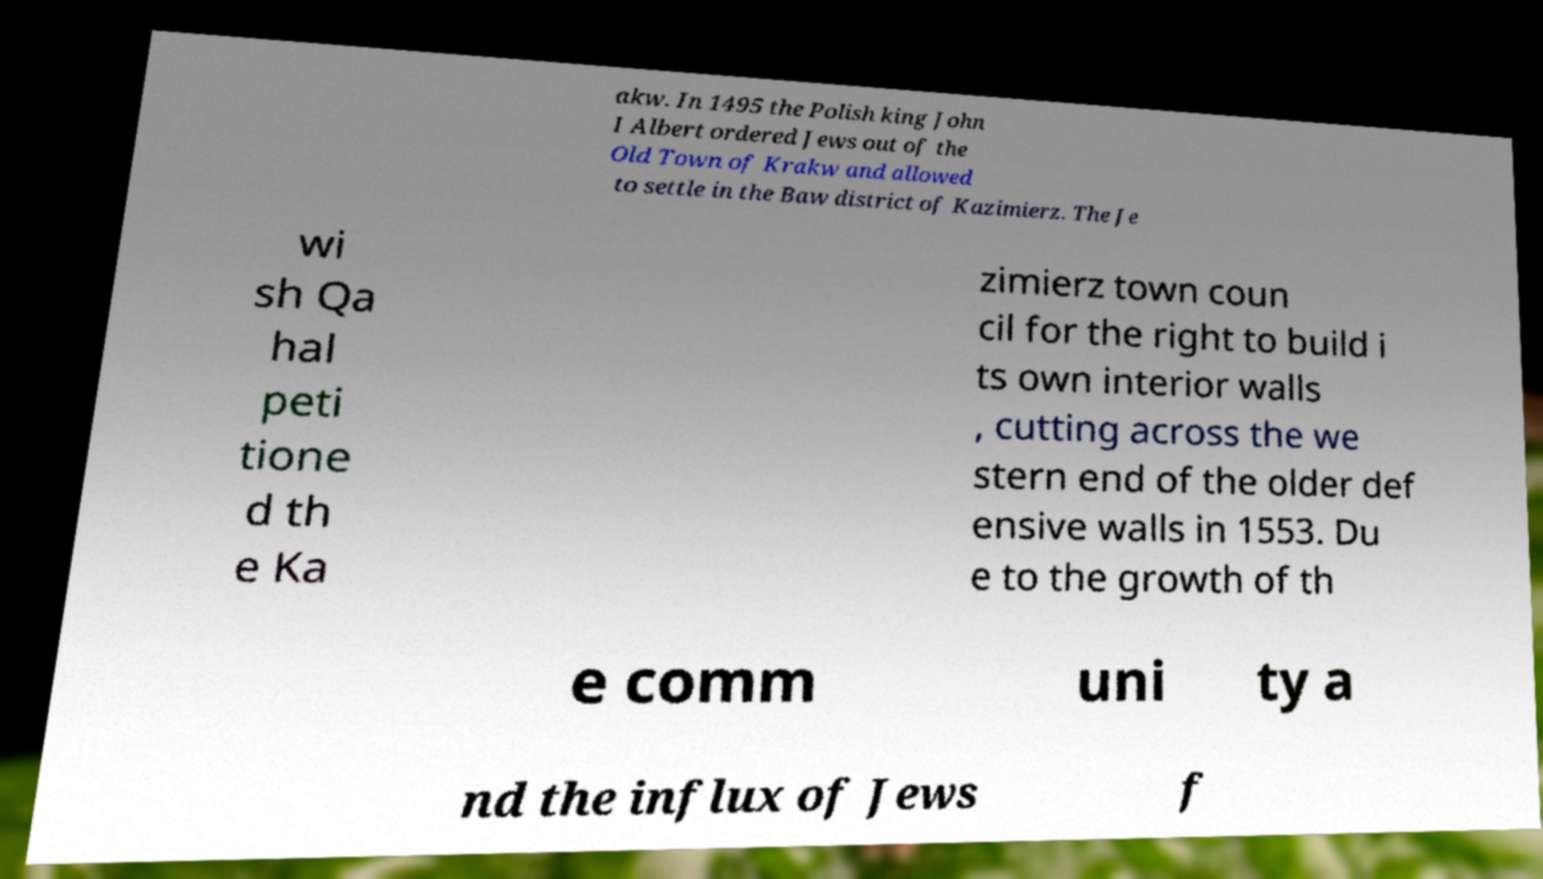Could you extract and type out the text from this image? akw. In 1495 the Polish king John I Albert ordered Jews out of the Old Town of Krakw and allowed to settle in the Baw district of Kazimierz. The Je wi sh Qa hal peti tione d th e Ka zimierz town coun cil for the right to build i ts own interior walls , cutting across the we stern end of the older def ensive walls in 1553. Du e to the growth of th e comm uni ty a nd the influx of Jews f 